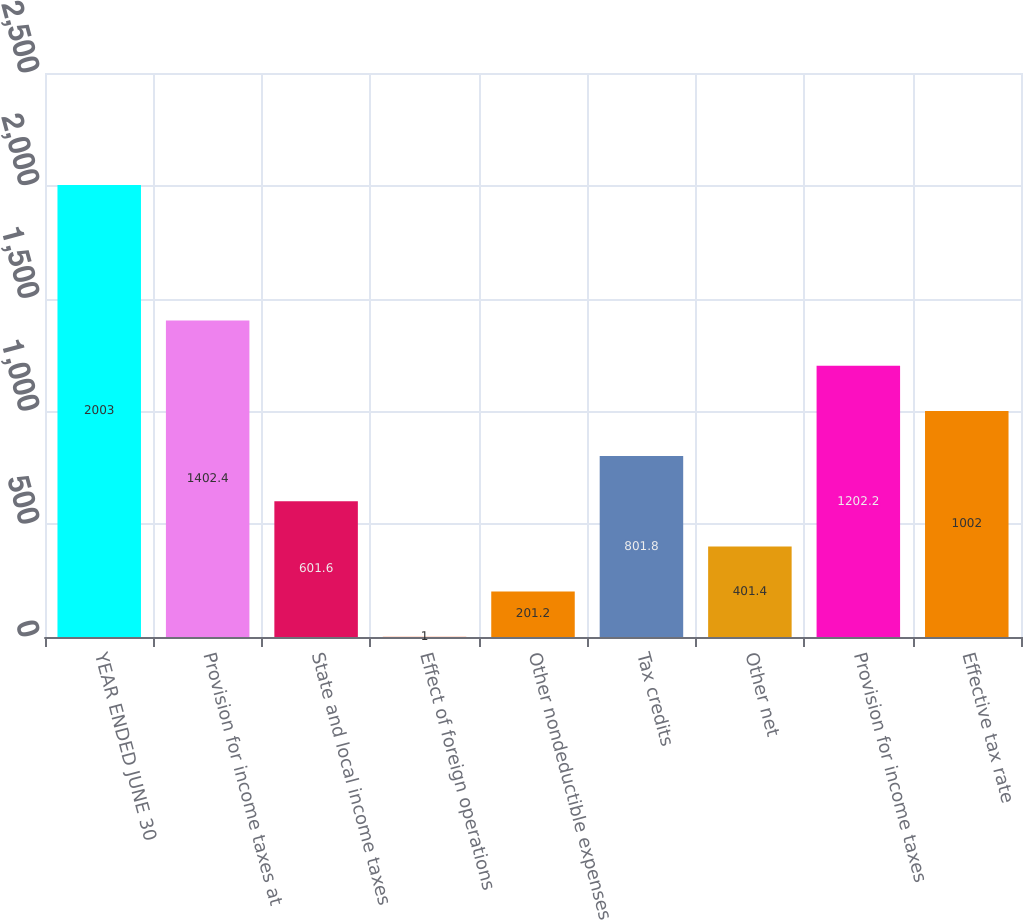Convert chart. <chart><loc_0><loc_0><loc_500><loc_500><bar_chart><fcel>YEAR ENDED JUNE 30<fcel>Provision for income taxes at<fcel>State and local income taxes<fcel>Effect of foreign operations<fcel>Other nondeductible expenses<fcel>Tax credits<fcel>Other net<fcel>Provision for income taxes<fcel>Effective tax rate<nl><fcel>2003<fcel>1402.4<fcel>601.6<fcel>1<fcel>201.2<fcel>801.8<fcel>401.4<fcel>1202.2<fcel>1002<nl></chart> 